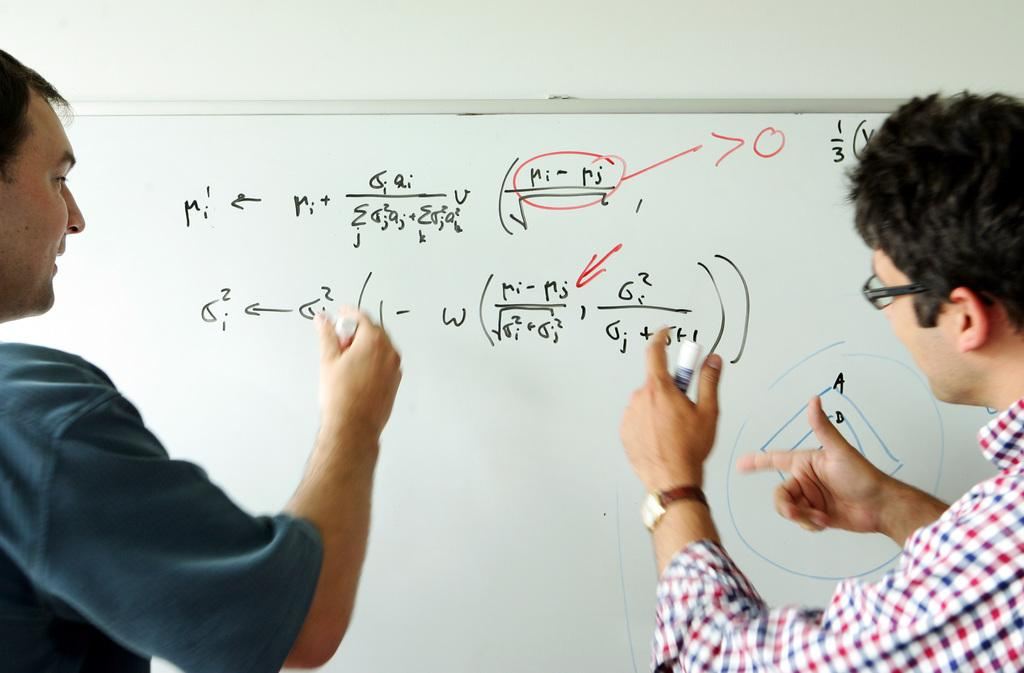How many people are in the foreground of the picture? There are two men in the foreground of the picture. What are the men holding in their hands? The men are holding markers. What is located in the center of the picture? There is a board in the center of the picture. What can be seen on the board? There is text on the board. What type of star can be seen in the caption on the board? There is no star or caption present on the board in the image. What type of fork is being used by the men to write on the board? The men are not using a fork to write on the board; they are holding markers. 